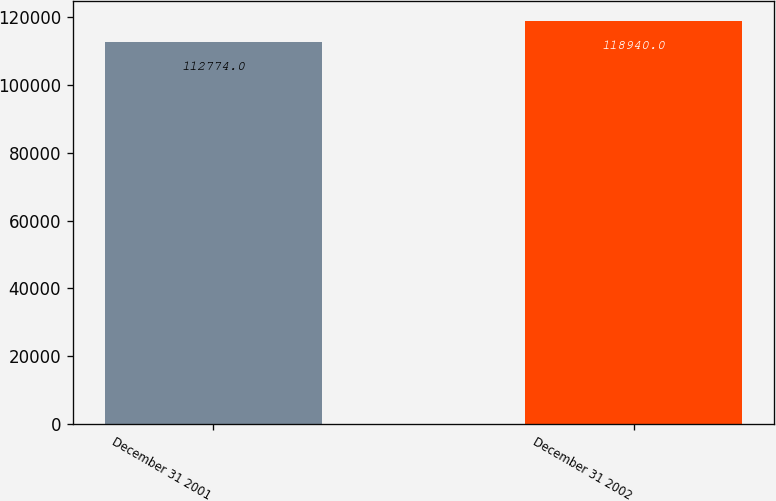Convert chart. <chart><loc_0><loc_0><loc_500><loc_500><bar_chart><fcel>December 31 2001<fcel>December 31 2002<nl><fcel>112774<fcel>118940<nl></chart> 